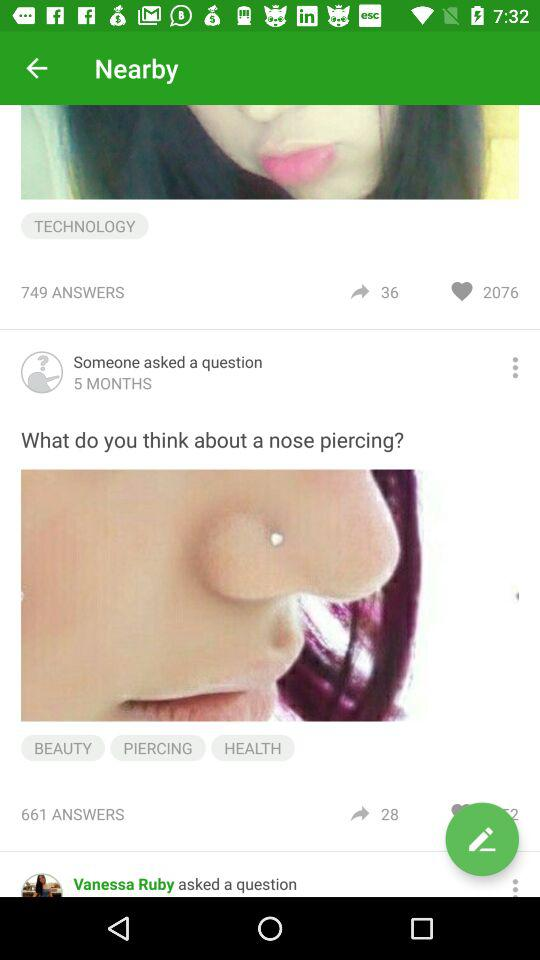When was "What do you think about a nose piercing?" posted? It was posted 5 months ago. 